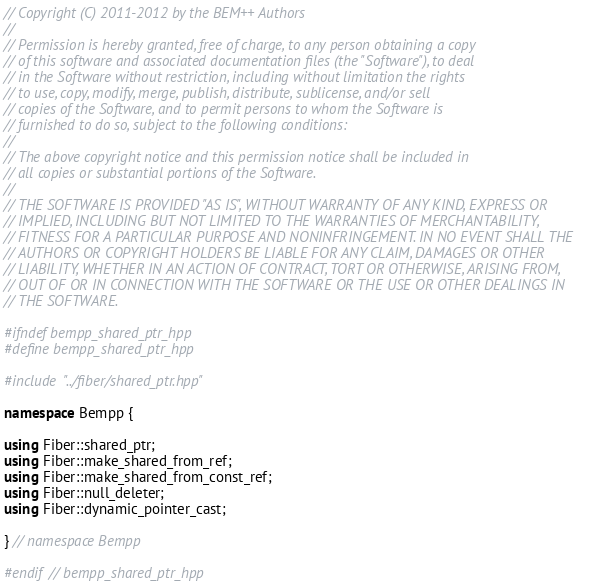Convert code to text. <code><loc_0><loc_0><loc_500><loc_500><_C++_>// Copyright (C) 2011-2012 by the BEM++ Authors
//
// Permission is hereby granted, free of charge, to any person obtaining a copy
// of this software and associated documentation files (the "Software"), to deal
// in the Software without restriction, including without limitation the rights
// to use, copy, modify, merge, publish, distribute, sublicense, and/or sell
// copies of the Software, and to permit persons to whom the Software is
// furnished to do so, subject to the following conditions:
//
// The above copyright notice and this permission notice shall be included in
// all copies or substantial portions of the Software.
//
// THE SOFTWARE IS PROVIDED "AS IS", WITHOUT WARRANTY OF ANY KIND, EXPRESS OR
// IMPLIED, INCLUDING BUT NOT LIMITED TO THE WARRANTIES OF MERCHANTABILITY,
// FITNESS FOR A PARTICULAR PURPOSE AND NONINFRINGEMENT. IN NO EVENT SHALL THE
// AUTHORS OR COPYRIGHT HOLDERS BE LIABLE FOR ANY CLAIM, DAMAGES OR OTHER
// LIABILITY, WHETHER IN AN ACTION OF CONTRACT, TORT OR OTHERWISE, ARISING FROM,
// OUT OF OR IN CONNECTION WITH THE SOFTWARE OR THE USE OR OTHER DEALINGS IN
// THE SOFTWARE.

#ifndef bempp_shared_ptr_hpp
#define bempp_shared_ptr_hpp

#include "../fiber/shared_ptr.hpp"

namespace Bempp {

using Fiber::shared_ptr;
using Fiber::make_shared_from_ref;
using Fiber::make_shared_from_const_ref;
using Fiber::null_deleter;
using Fiber::dynamic_pointer_cast;

} // namespace Bempp

#endif // bempp_shared_ptr_hpp
</code> 